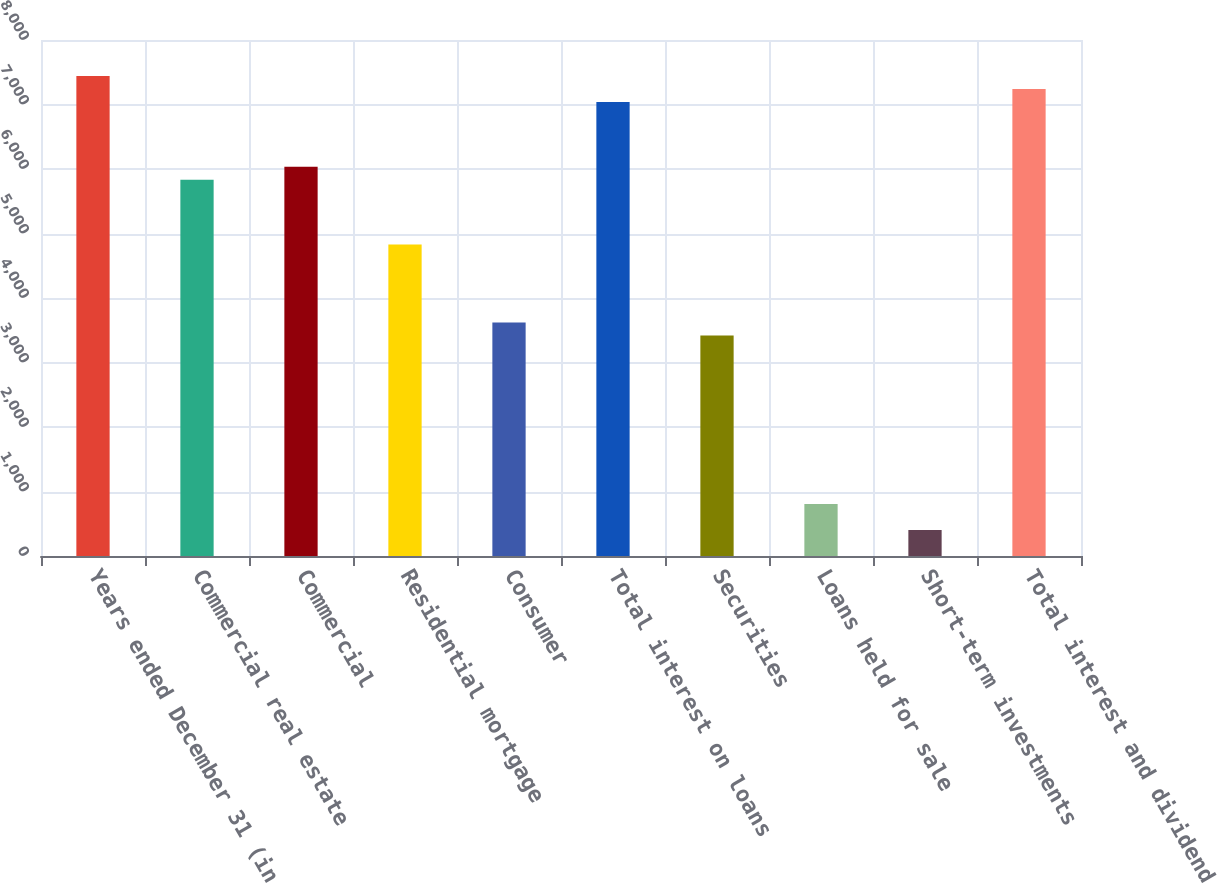<chart> <loc_0><loc_0><loc_500><loc_500><bar_chart><fcel>Years ended December 31 (in<fcel>Commercial real estate<fcel>Commercial<fcel>Residential mortgage<fcel>Consumer<fcel>Total interest on loans<fcel>Securities<fcel>Loans held for sale<fcel>Short-term investments<fcel>Total interest and dividend<nl><fcel>7442.53<fcel>5833.49<fcel>6034.62<fcel>4827.84<fcel>3621.06<fcel>7040.27<fcel>3419.93<fcel>805.24<fcel>402.98<fcel>7241.4<nl></chart> 